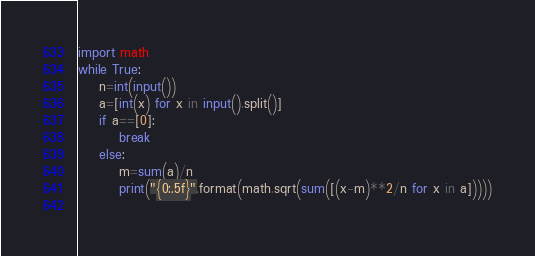<code> <loc_0><loc_0><loc_500><loc_500><_Python_>import math
while True:
    n=int(input())
    a=[int(x) for x in input().split()]
    if a==[0]:
        break
    else:
        m=sum(a)/n
        print("{0:.5f}".format(math.sqrt(sum([(x-m)**2/n for x in a]))))
 </code> 